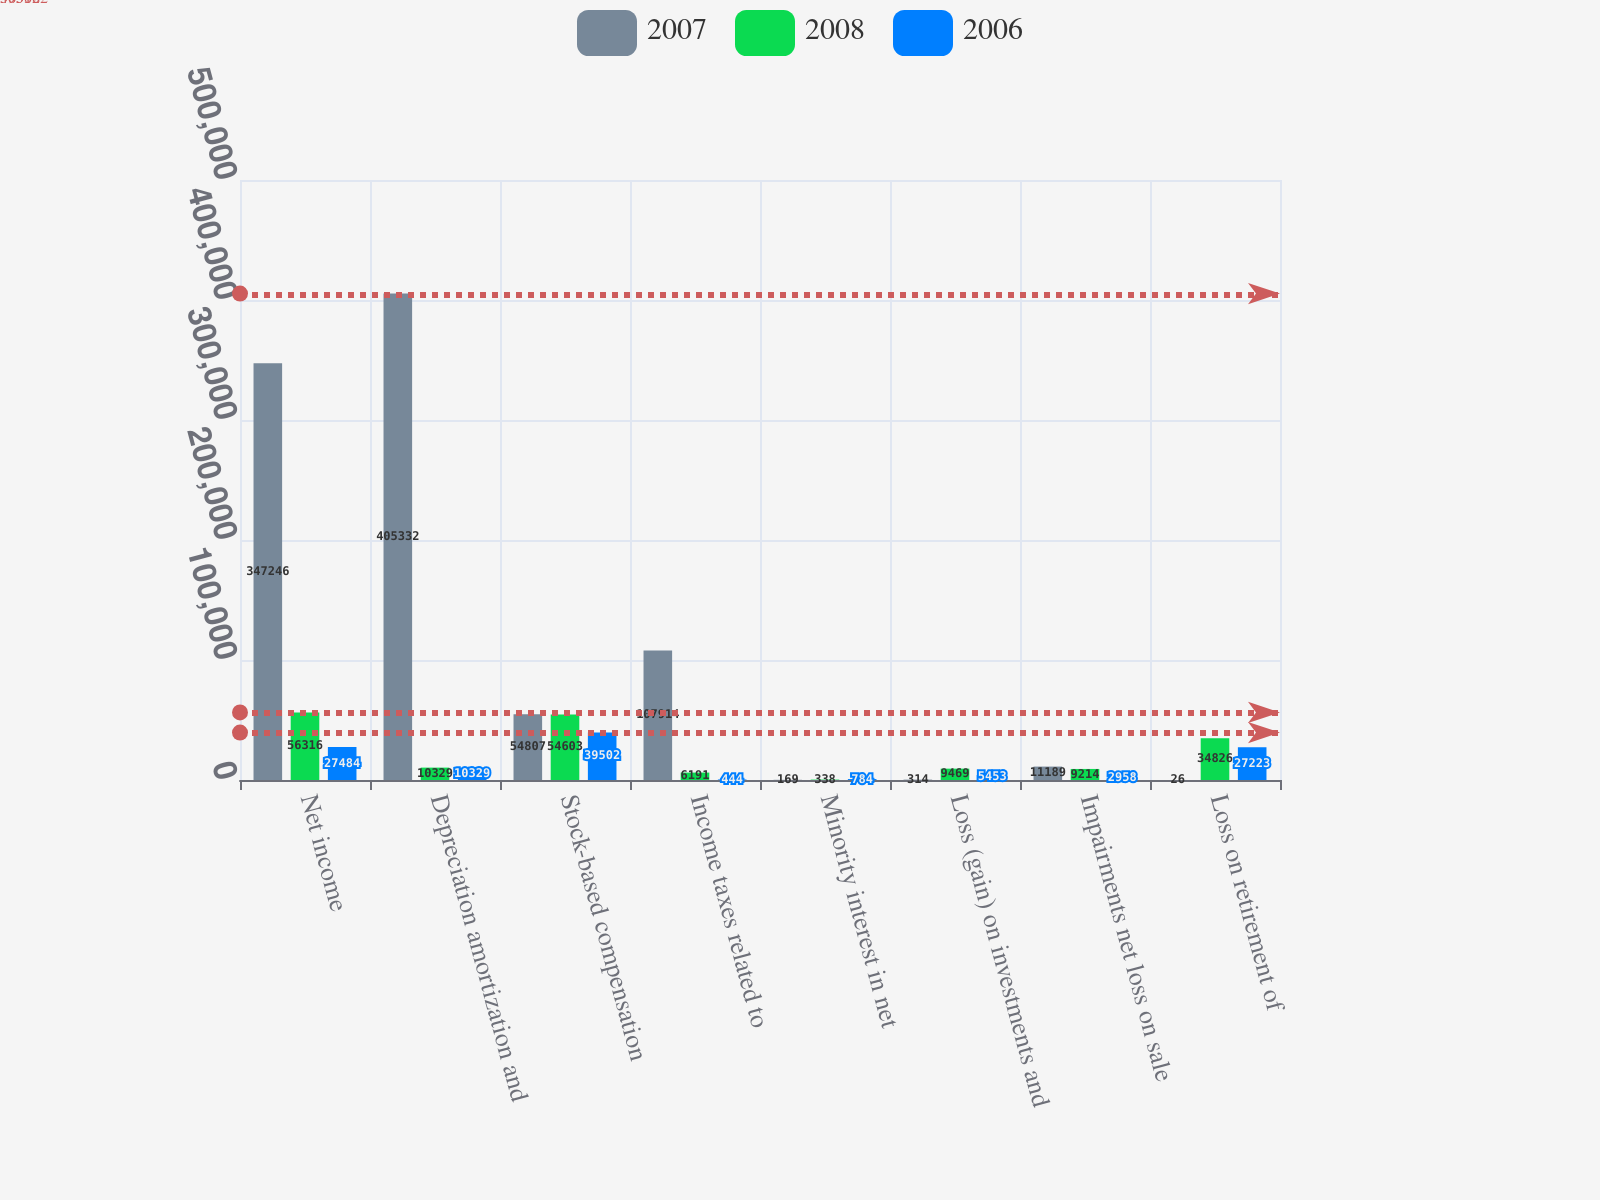<chart> <loc_0><loc_0><loc_500><loc_500><stacked_bar_chart><ecel><fcel>Net income<fcel>Depreciation amortization and<fcel>Stock-based compensation<fcel>Income taxes related to<fcel>Minority interest in net<fcel>Loss (gain) on investments and<fcel>Impairments net loss on sale<fcel>Loss on retirement of<nl><fcel>2007<fcel>347246<fcel>405332<fcel>54807<fcel>107914<fcel>169<fcel>314<fcel>11189<fcel>26<nl><fcel>2008<fcel>56316<fcel>10329<fcel>54603<fcel>6191<fcel>338<fcel>9469<fcel>9214<fcel>34826<nl><fcel>2006<fcel>27484<fcel>10329<fcel>39502<fcel>444<fcel>784<fcel>5453<fcel>2958<fcel>27223<nl></chart> 